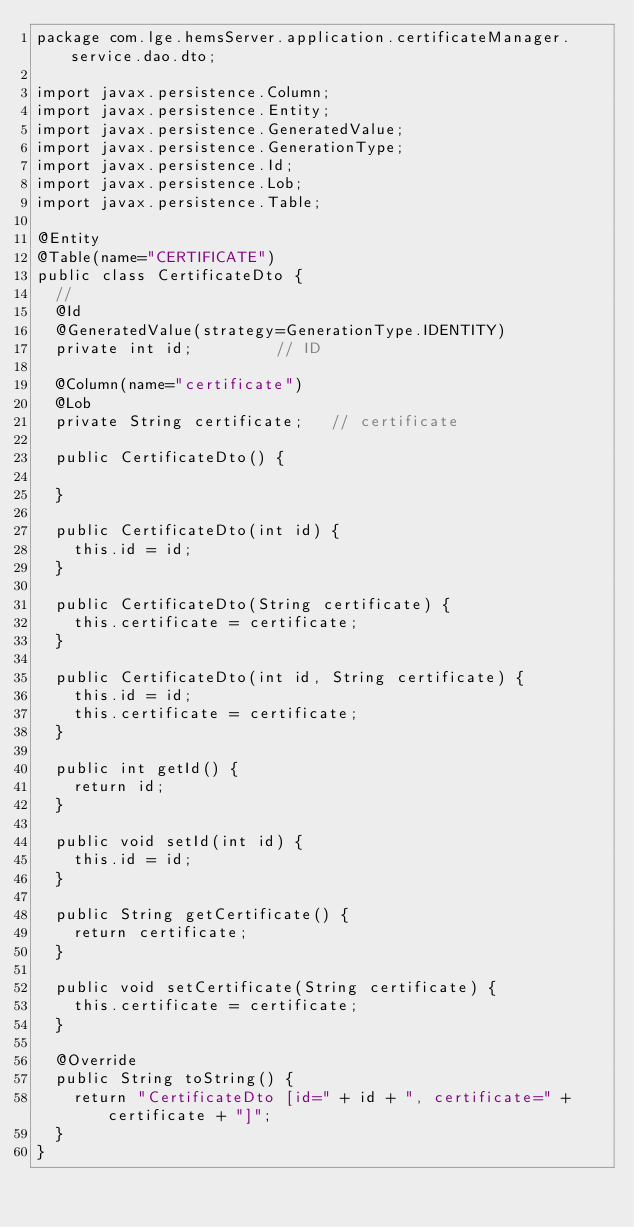Convert code to text. <code><loc_0><loc_0><loc_500><loc_500><_Java_>package com.lge.hemsServer.application.certificateManager.service.dao.dto;

import javax.persistence.Column;
import javax.persistence.Entity;
import javax.persistence.GeneratedValue;
import javax.persistence.GenerationType;
import javax.persistence.Id;
import javax.persistence.Lob;
import javax.persistence.Table;

@Entity
@Table(name="CERTIFICATE")
public class CertificateDto {
	//
	@Id
	@GeneratedValue(strategy=GenerationType.IDENTITY)
	private int id;					// ID
	
	@Column(name="certificate")
	@Lob
	private String certificate;		// certificate
	
	public CertificateDto() {
		
	}
	
	public CertificateDto(int id) {
		this.id = id;
	}
	
	public CertificateDto(String certificate) {
		this.certificate = certificate;
	}
	
	public CertificateDto(int id, String certificate) {
		this.id = id;
		this.certificate = certificate;
	}

	public int getId() {
		return id;
	}

	public void setId(int id) {
		this.id = id;
	}

	public String getCertificate() {
		return certificate;
	}

	public void setCertificate(String certificate) {
		this.certificate = certificate;
	}

	@Override
	public String toString() {
		return "CertificateDto [id=" + id + ", certificate=" + certificate + "]";
	}
}</code> 